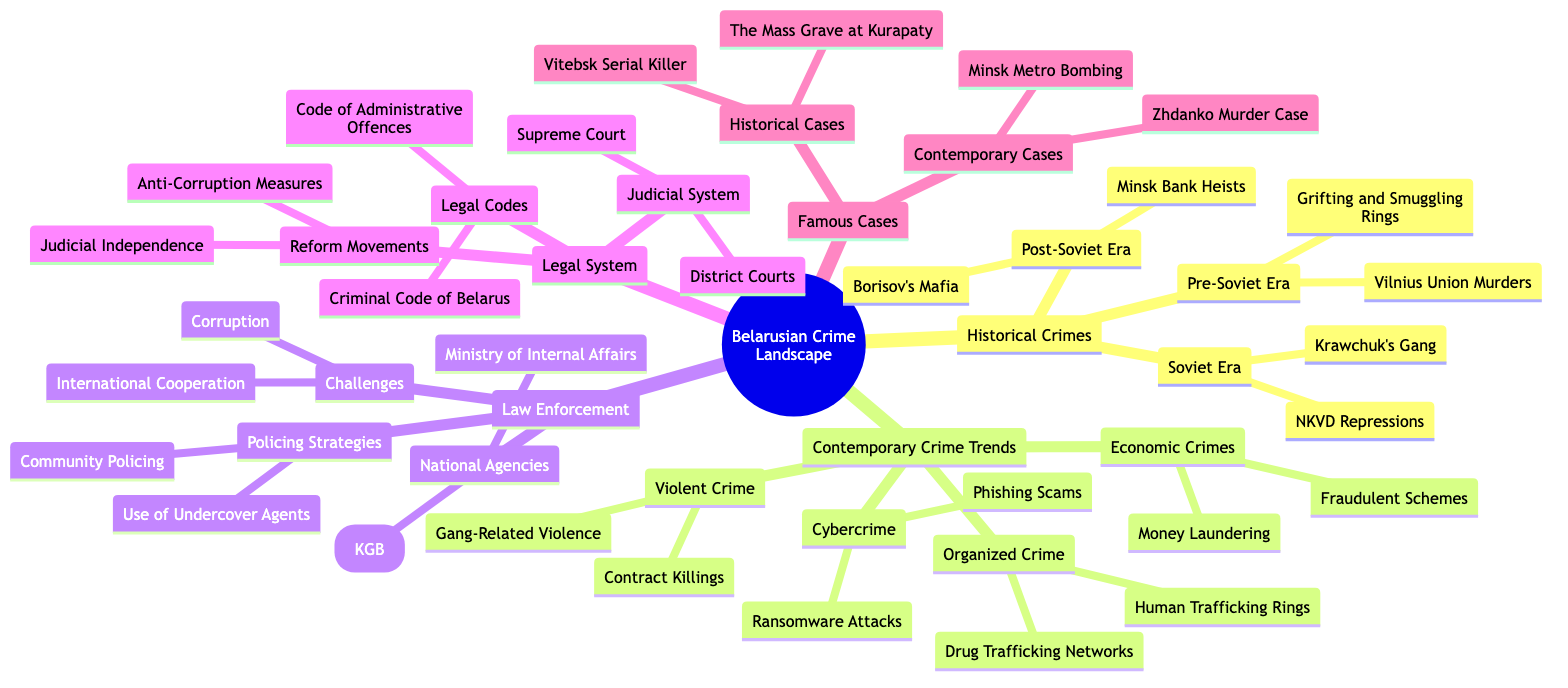What are two crimes in the Soviet Era? The diagram lists "NKVD Repressions" and "Krawchuk's Gang" as examples of crimes that occurred during the Soviet Era under the category of Historical Crimes.
Answer: NKVD Repressions, Krawchuk's Gang How many contemporary crime trends are listed? The diagram shows that there are four main categories under Contemporary Crime Trends: Organized Crime, Cybercrime, Economic Crimes, and Violent Crime. Therefore, the answer is 4.
Answer: 4 What type of crime involves "Money Laundering"? "Money Laundering" is categorized under Economic Crimes in the Contemporary Crime Trends section of the diagram.
Answer: Economic Crimes Which national agency is responsible for internal affairs? The diagram specifically identifies the "Ministry of Internal Affairs" as one of the national agencies related to law enforcement.
Answer: Ministry of Internal Affairs What is one challenge faced by law enforcement in Belarus? The diagram lists "Corruption" as a challenge within the Law Enforcement category, indicating significant issues that affect their effectiveness.
Answer: Corruption Which case is associated with a mass grave? The "Mass Grave at Kurapaty" is noted as a Historical Case within the Famous Cases section of the diagram.
Answer: The Mass Grave at Kurapaty What are the two types of policing strategies mentioned? The diagram features "Community Policing" and "Use of Undercover Agents" as the specific policing strategies listed in the Law Enforcement section.
Answer: Community Policing, Use of Undercover Agents How many famous historical cases are identified? The diagram shows that there are two cases listed under Historical Cases: "The Mass Grave at Kurapaty" and "Vitebsk Serial Killer". Therefore, the answer is 2.
Answer: 2 Which category includes "Phishing Scams"? "Phishing Scams" is classified under Cybercrime within the Contemporary Crime Trends segment of the diagram.
Answer: Cybercrime 